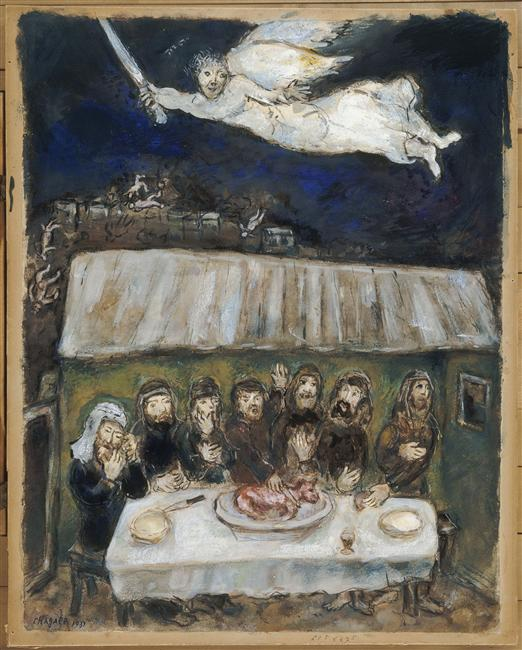Can you describe the main features of this image for me? The image depicts a mystic and dramatically surreal scene set in a dimly lit environment, primarily in hues of deep blues and earthy tones. Central to the scene is a group of figures gathered around a rustic table, focused intently on an anomalous piece of meat. Above them floats an angelic figure wielding a large sword, her form casting a stark contrast against the night sky. The setting outside the humble dwelling shows sparse trees and hints of distant structures, suggesting a remote locale. The painting's style, marked by broad, dynamic strokes and distorted forms, heightens the sense of tension and otherworldliness. This artwork could be seen as a symbolic exploration of themes like sacrifice, protection, and the supernatural. 